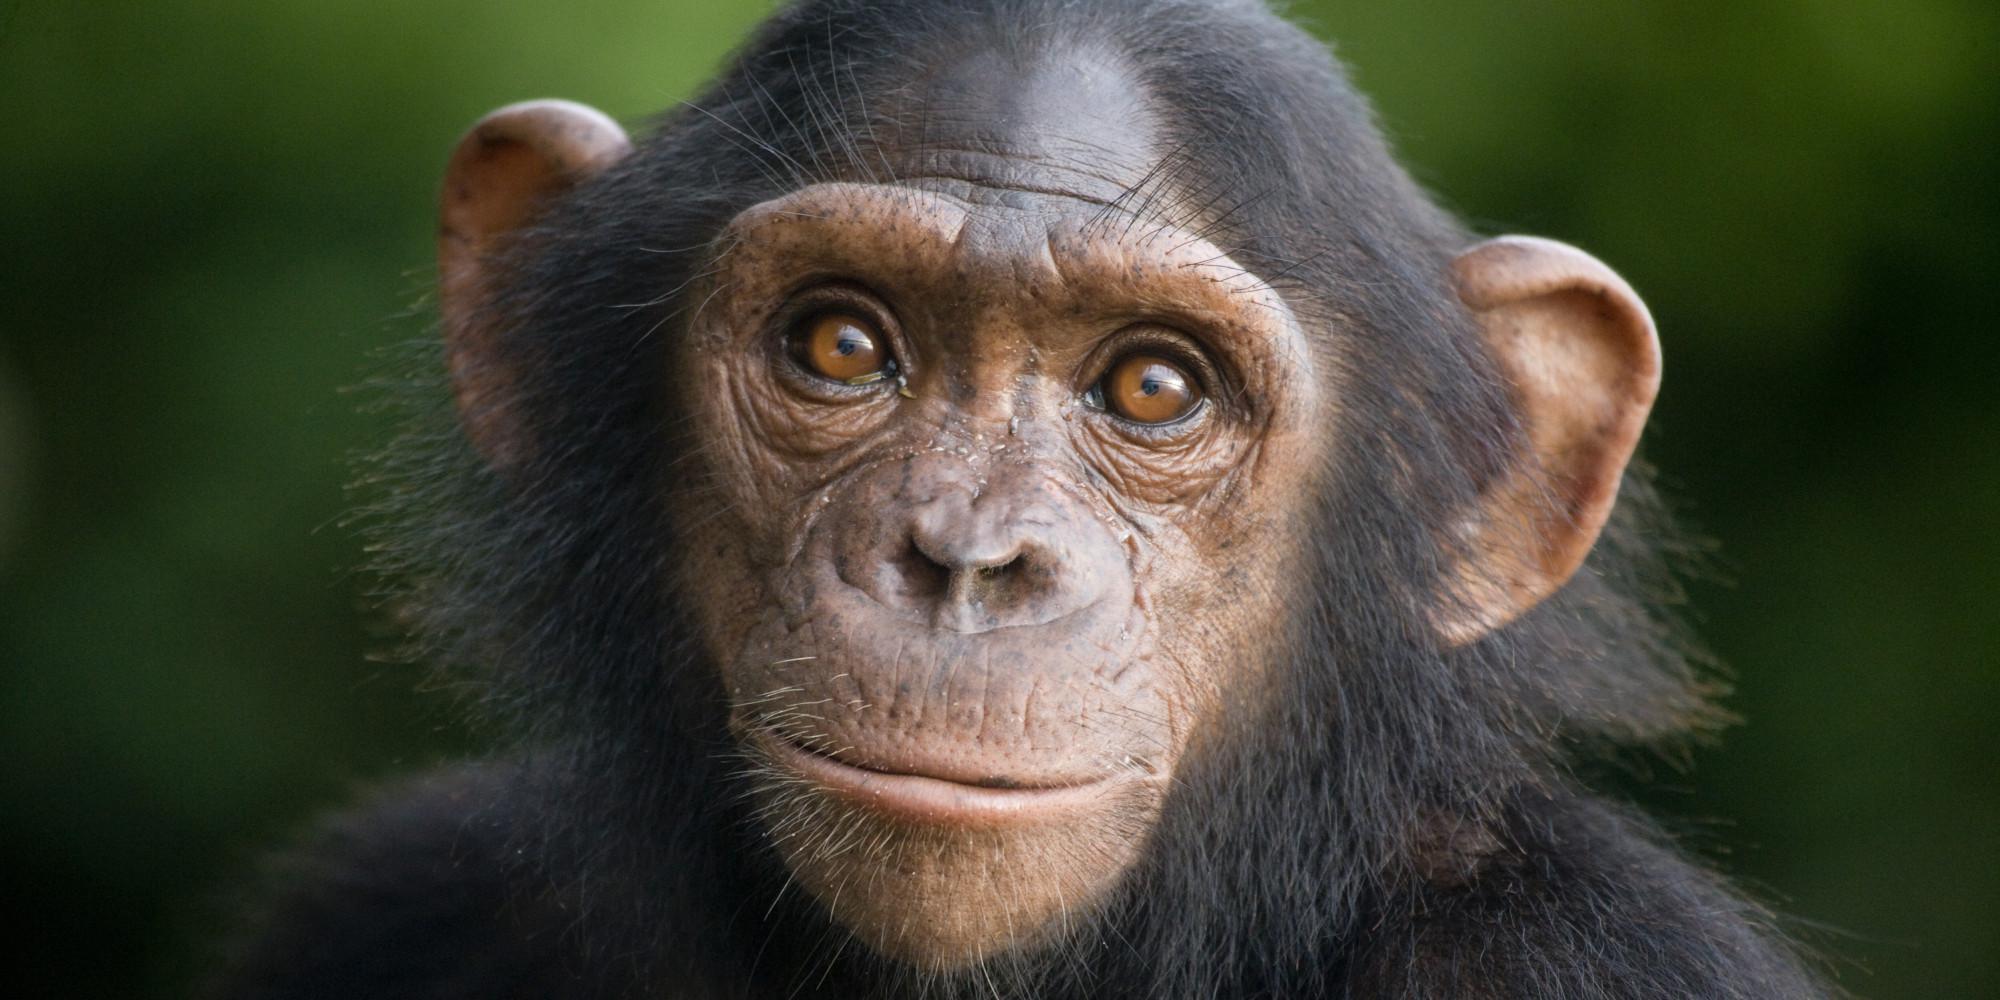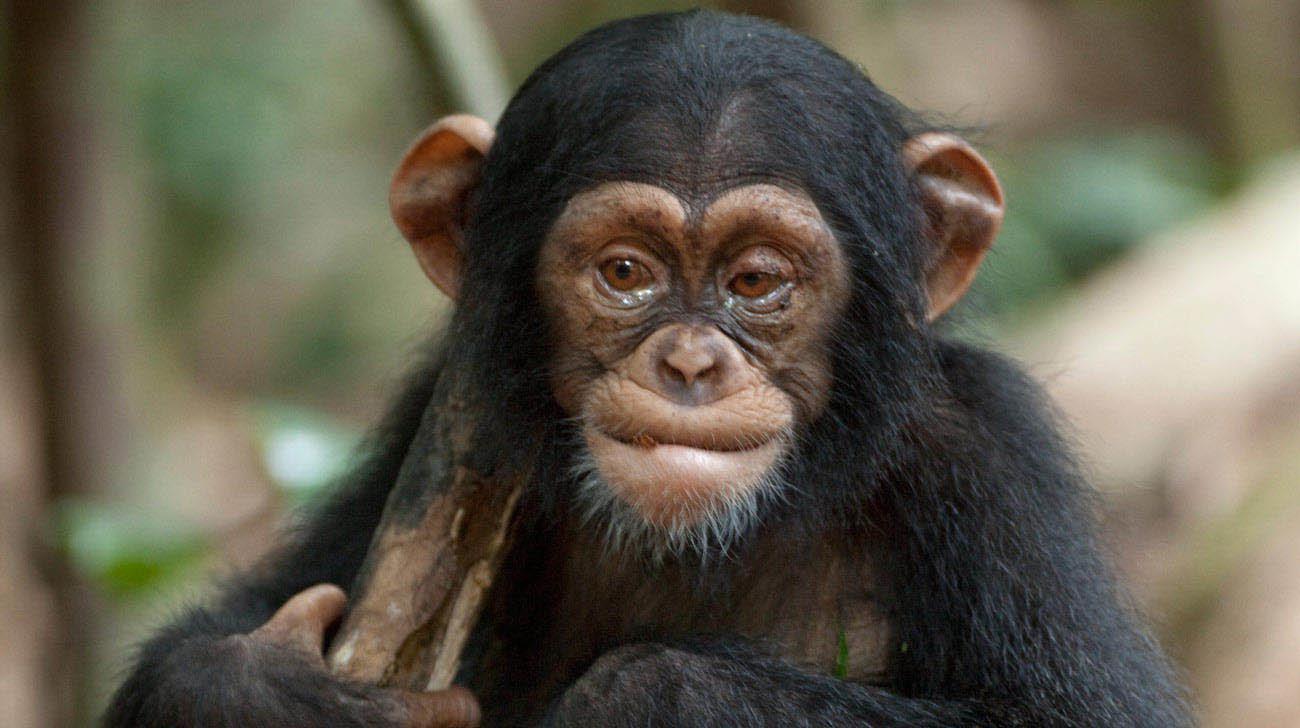The first image is the image on the left, the second image is the image on the right. Evaluate the accuracy of this statement regarding the images: "There are two monkeys in the image on the right.". Is it true? Answer yes or no. No. 